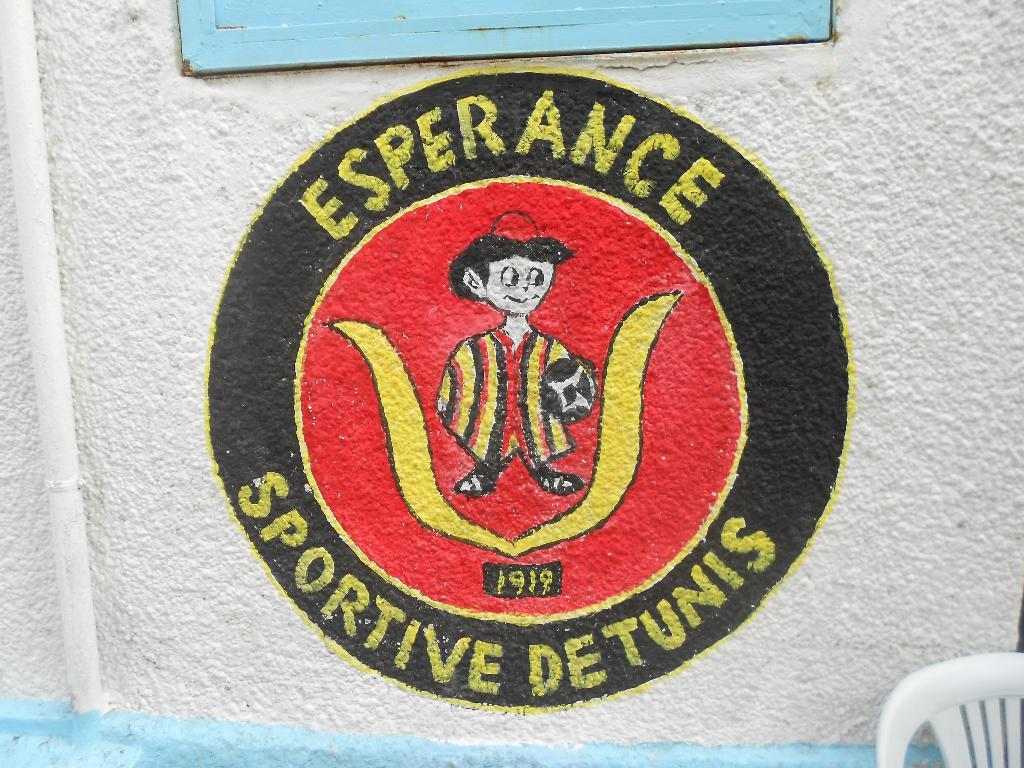What is the main subject of the image? There is a painting in the image. What else can be seen in the image besides the painting? There is text and a wooden structure on the wall, as well as a pipe attached to the wooden structure. Is there any furniture in the image? Yes, there is a chair in front of the wall. How many pigs are rolling around on the floor in the image? There are no pigs present in the image, and therefore no rolling pigs can be observed. What part of the brain is depicted in the painting? The painting does not depict any part of the brain; it is not mentioned in the provided facts. 